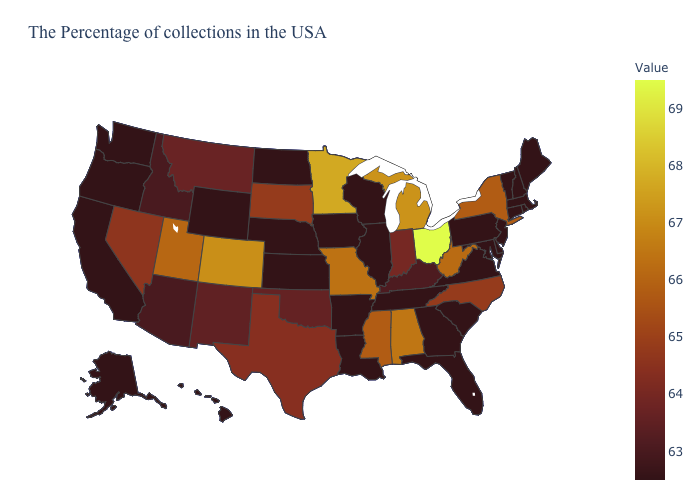Among the states that border Indiana , which have the highest value?
Be succinct. Ohio. Which states hav the highest value in the South?
Keep it brief. Alabama. Which states have the highest value in the USA?
Give a very brief answer. Ohio. Does the map have missing data?
Be succinct. No. Does the map have missing data?
Quick response, please. No. Does Ohio have the highest value in the USA?
Be succinct. Yes. Does Kentucky have the lowest value in the South?
Be succinct. No. Among the states that border Colorado , does Oklahoma have the lowest value?
Short answer required. No. 